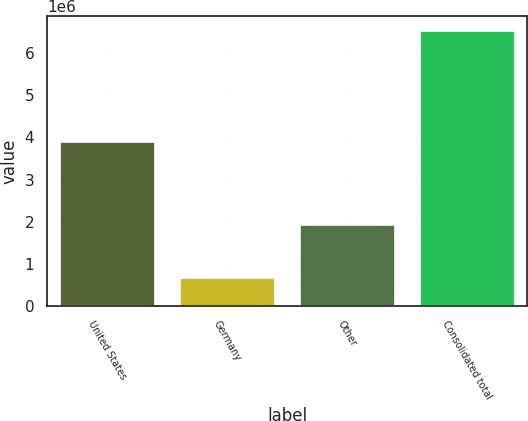<chart> <loc_0><loc_0><loc_500><loc_500><bar_chart><fcel>United States<fcel>Germany<fcel>Other<fcel>Consolidated total<nl><fcel>3.90235e+06<fcel>699309<fcel>1.93667e+06<fcel>6.53834e+06<nl></chart> 